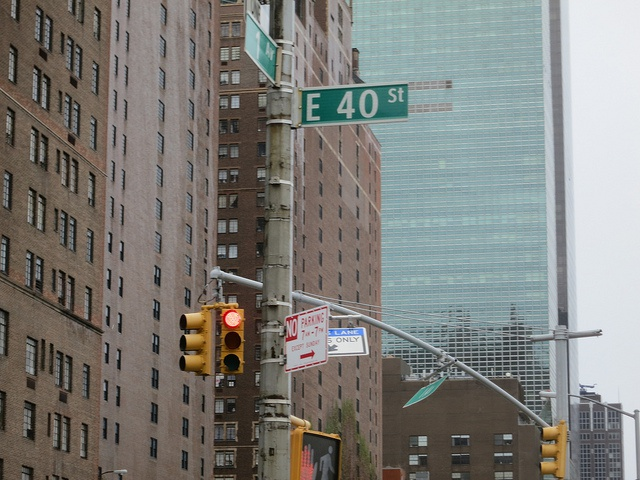Describe the objects in this image and their specific colors. I can see traffic light in black, olive, gray, and brown tones, traffic light in black, olive, and maroon tones, traffic light in black, olive, and maroon tones, and traffic light in black, tan, and olive tones in this image. 